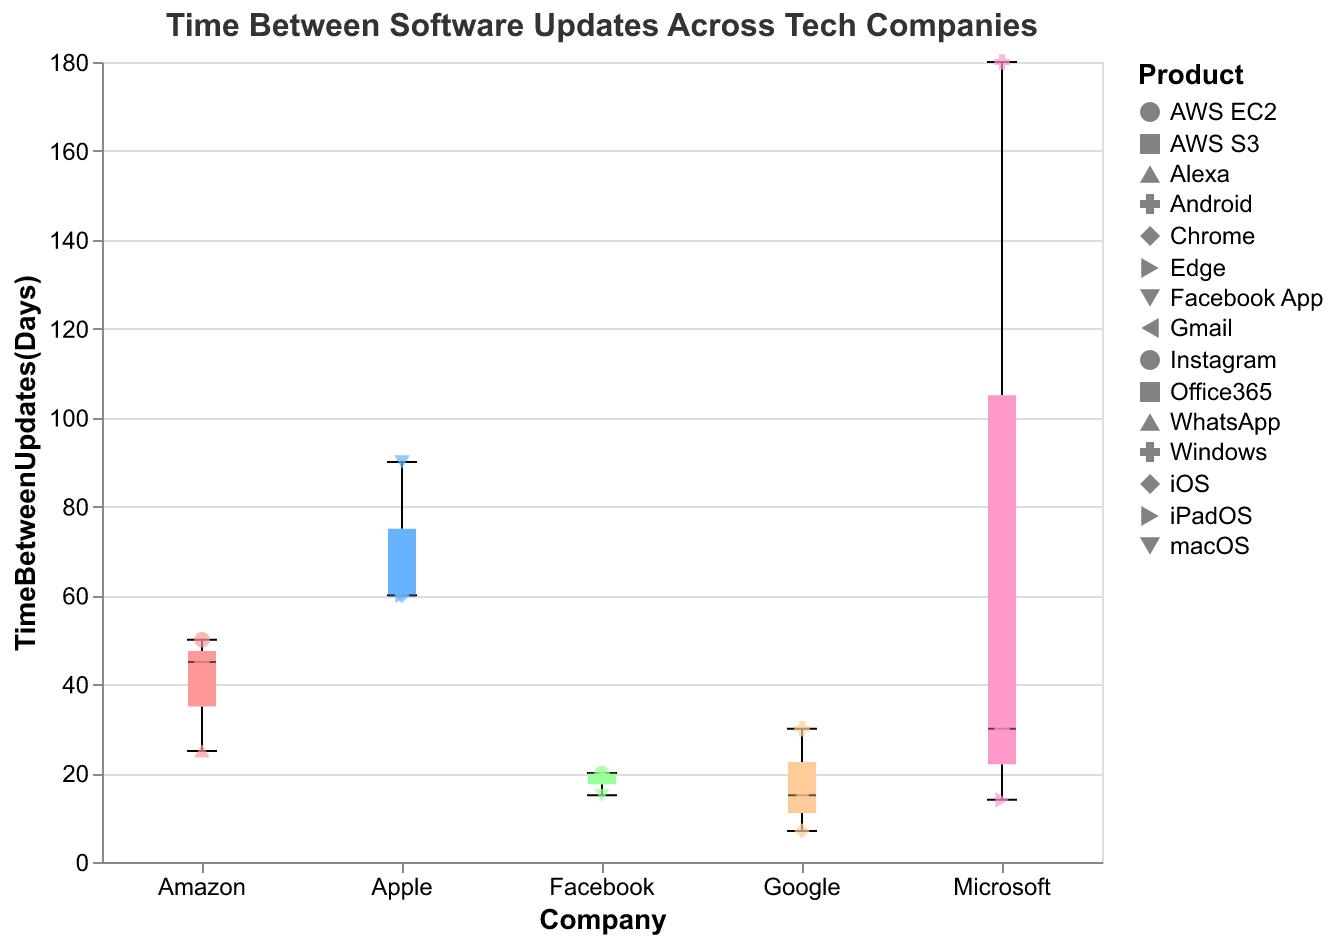What is the median time between updates for Apple? The median is shown as a line within the box plot for Apple.
Answer: 60 What is the range of time between updates for Microsoft products? The range of times between updates is shown by the whiskers extending to the minimum and maximum points in the box plot for Microsoft. The minimum is 14 days, and the maximum is 180 days.
Answer: 166 Which company has the smallest variability in time between updates? Variability is shown by the interquartile range (length of the box) in the box plot. Smaller boxes indicate less variability. Facebook has the smallest box among the companies.
Answer: Facebook Is there a product that updates more frequently than 10 days? Which one? Check the scatter points for any product below the 10-day mark. Google Chrome has a scatter point at 7 days.
Answer: Google Chrome Compare the median time between updates for Google's products vs. Amazon's products. Which company has a longer median update time? Google's median update time is shown around 15 days, while Amazon's median update time is between 25-50 days. Thus, Amazon has a longer median update time.
Answer: Amazon How many products from each company are included in the plot? Count the scatter points (products) for each company from the figure. Apple has 3, Google has 4, Microsoft has 3, Amazon has 4, and Facebook has 3 products shown.
Answer: Apple: 3, Google: 4, Microsoft: 3, Amazon: 4, Facebook: 3 What is the maximum time between updates for Google products? The maximum time is represented by the highest whisker for Google in the box plot, which is 30 days for Android.
Answer: 30 Which product has the longest time between updates, and what is that time? Identify the scatter point that is highest above the y-axis. Microsoft Windows has the longest time between updates at 180 days.
Answer: Microsoft Windows, 180 days 